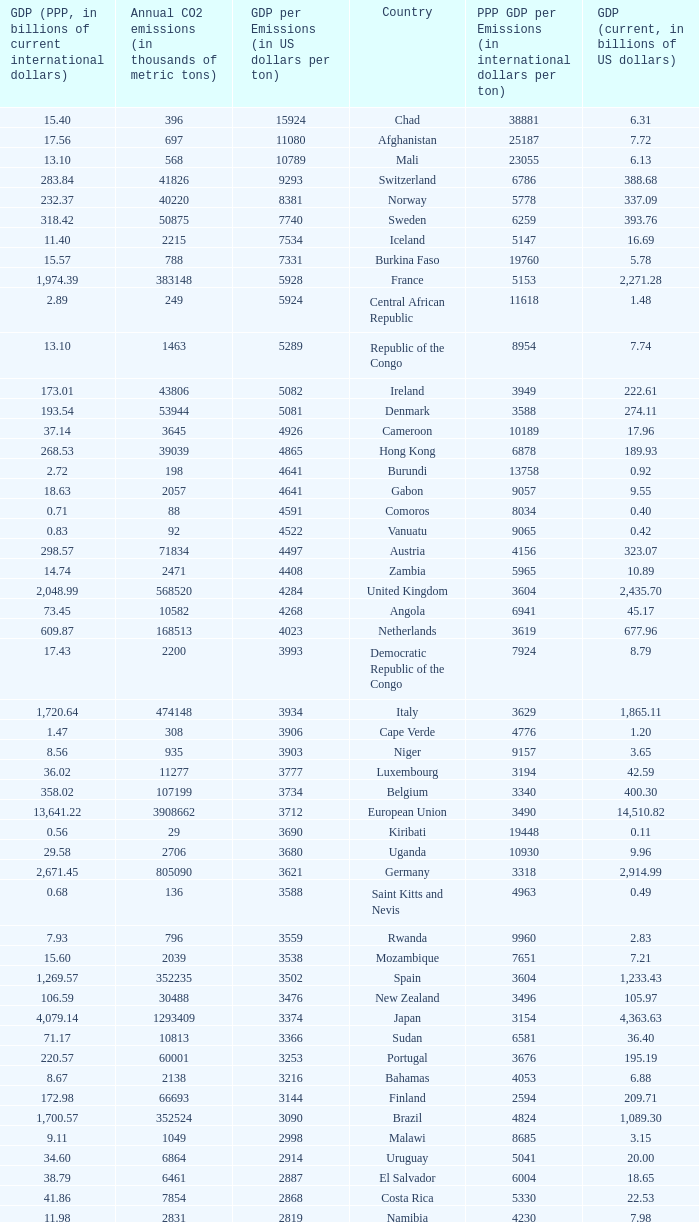For a country with an annual emission of 1,811 thousand metric tons of co2, what is its name? Haiti. 